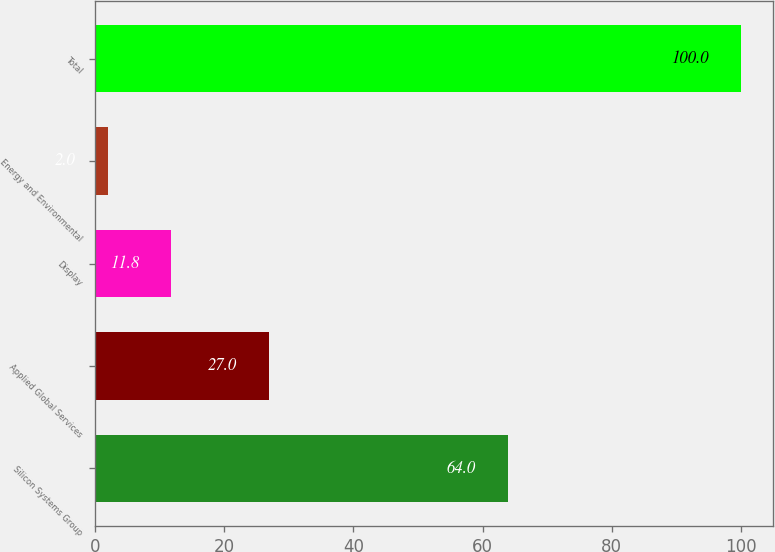Convert chart to OTSL. <chart><loc_0><loc_0><loc_500><loc_500><bar_chart><fcel>Silicon Systems Group<fcel>Applied Global Services<fcel>Display<fcel>Energy and Environmental<fcel>Total<nl><fcel>64<fcel>27<fcel>11.8<fcel>2<fcel>100<nl></chart> 